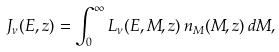<formula> <loc_0><loc_0><loc_500><loc_500>J _ { \nu } ( E , z ) = \int _ { 0 } ^ { \infty } L _ { \nu } ( E , M , z ) \, n _ { M } ( M , z ) \, d M ,</formula> 